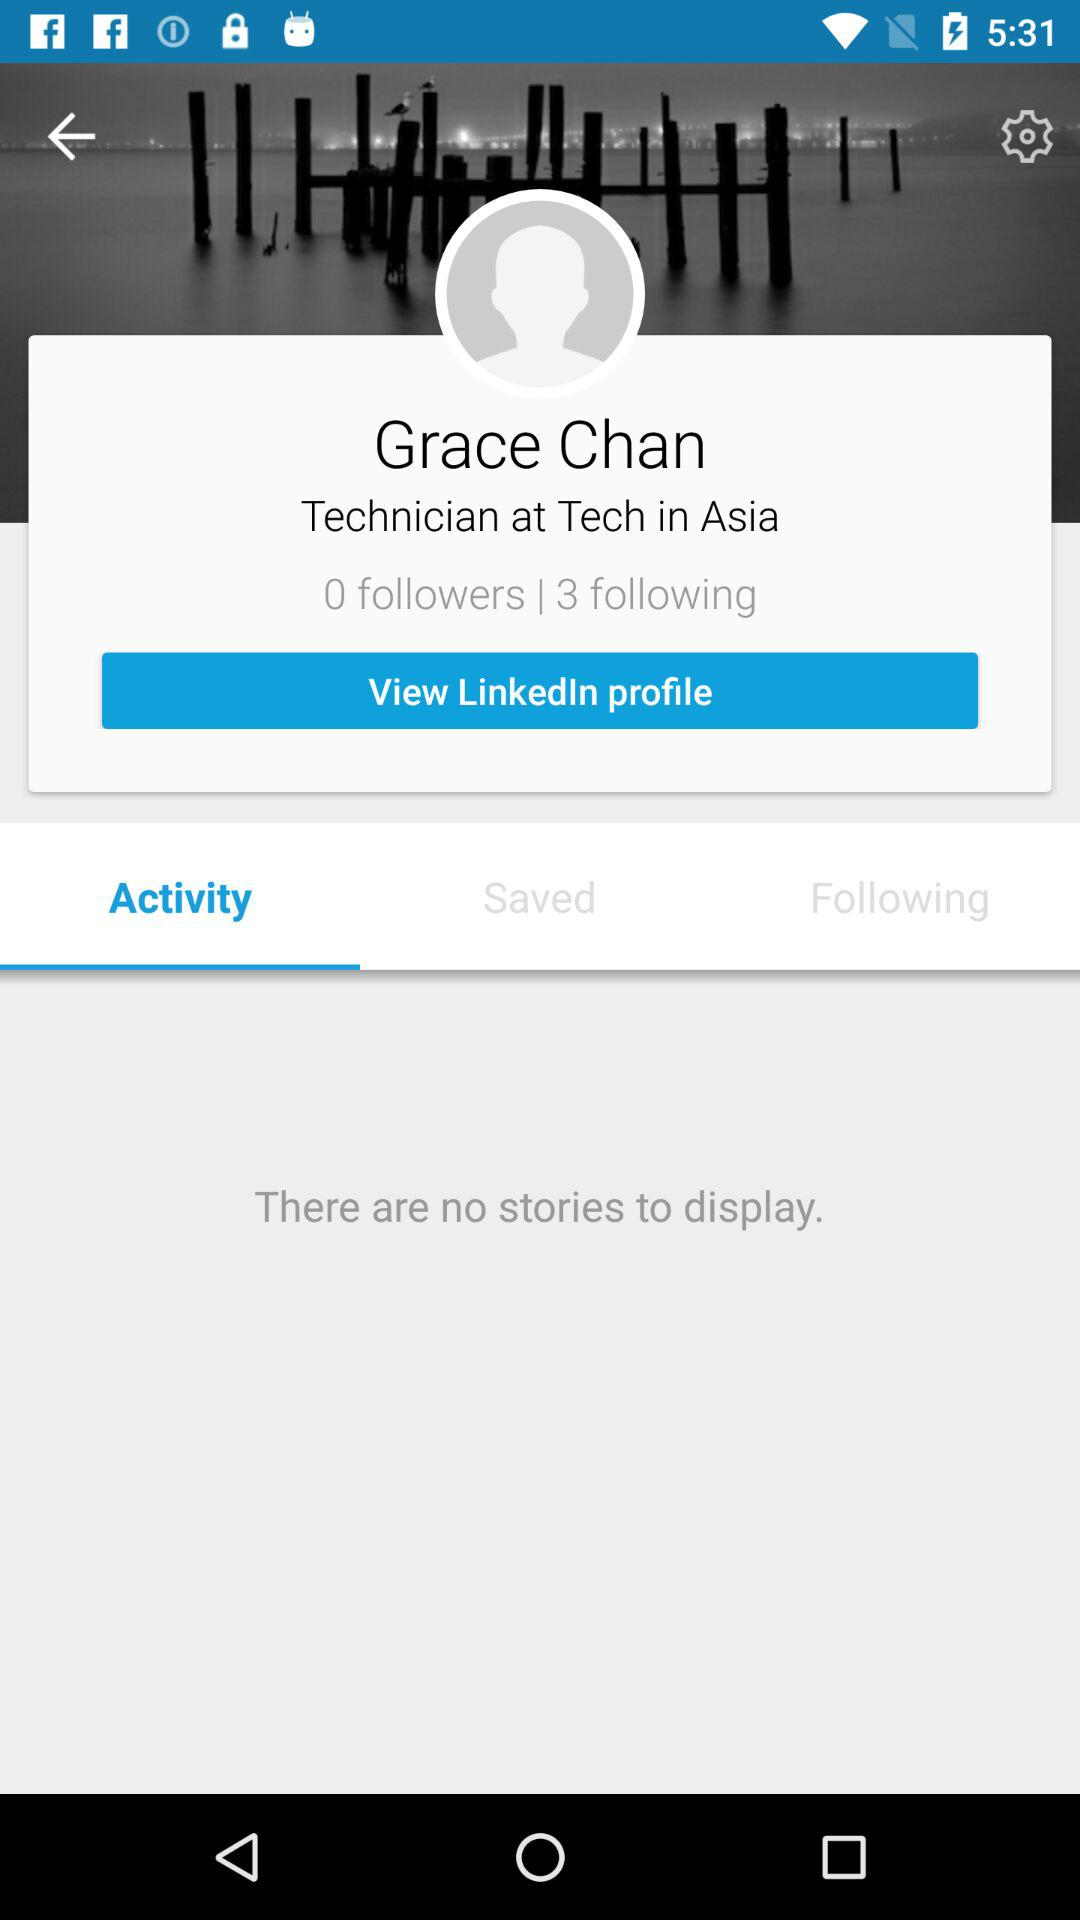What is the user name? The user name is Grace Chan. 